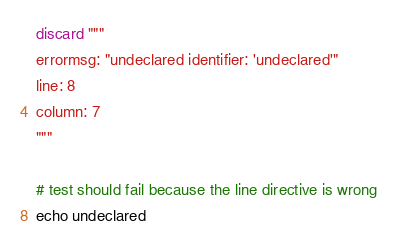Convert code to text. <code><loc_0><loc_0><loc_500><loc_500><_Nim_>discard """
errormsg: "undeclared identifier: 'undeclared'"
line: 8
column: 7
"""

# test should fail because the line directive is wrong
echo undeclared
</code> 